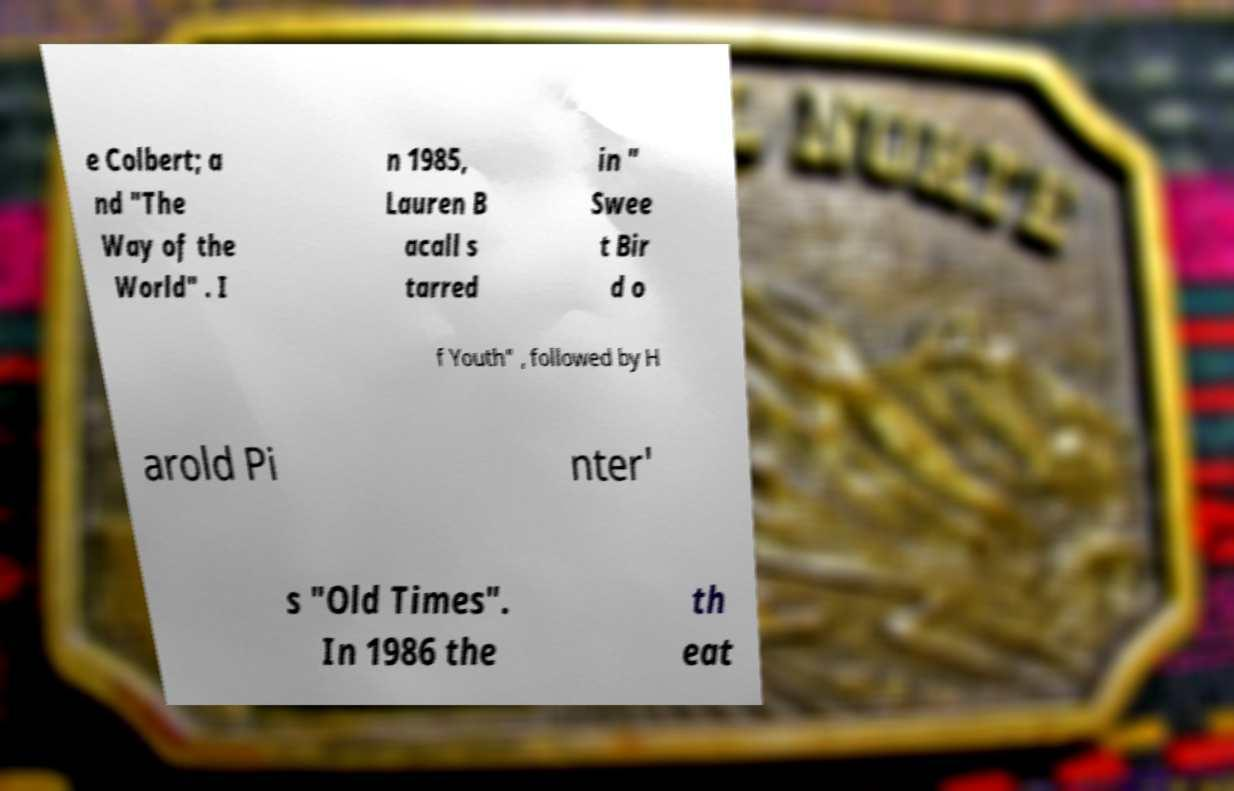Can you accurately transcribe the text from the provided image for me? e Colbert; a nd "The Way of the World" . I n 1985, Lauren B acall s tarred in " Swee t Bir d o f Youth" , followed by H arold Pi nter' s "Old Times". In 1986 the th eat 